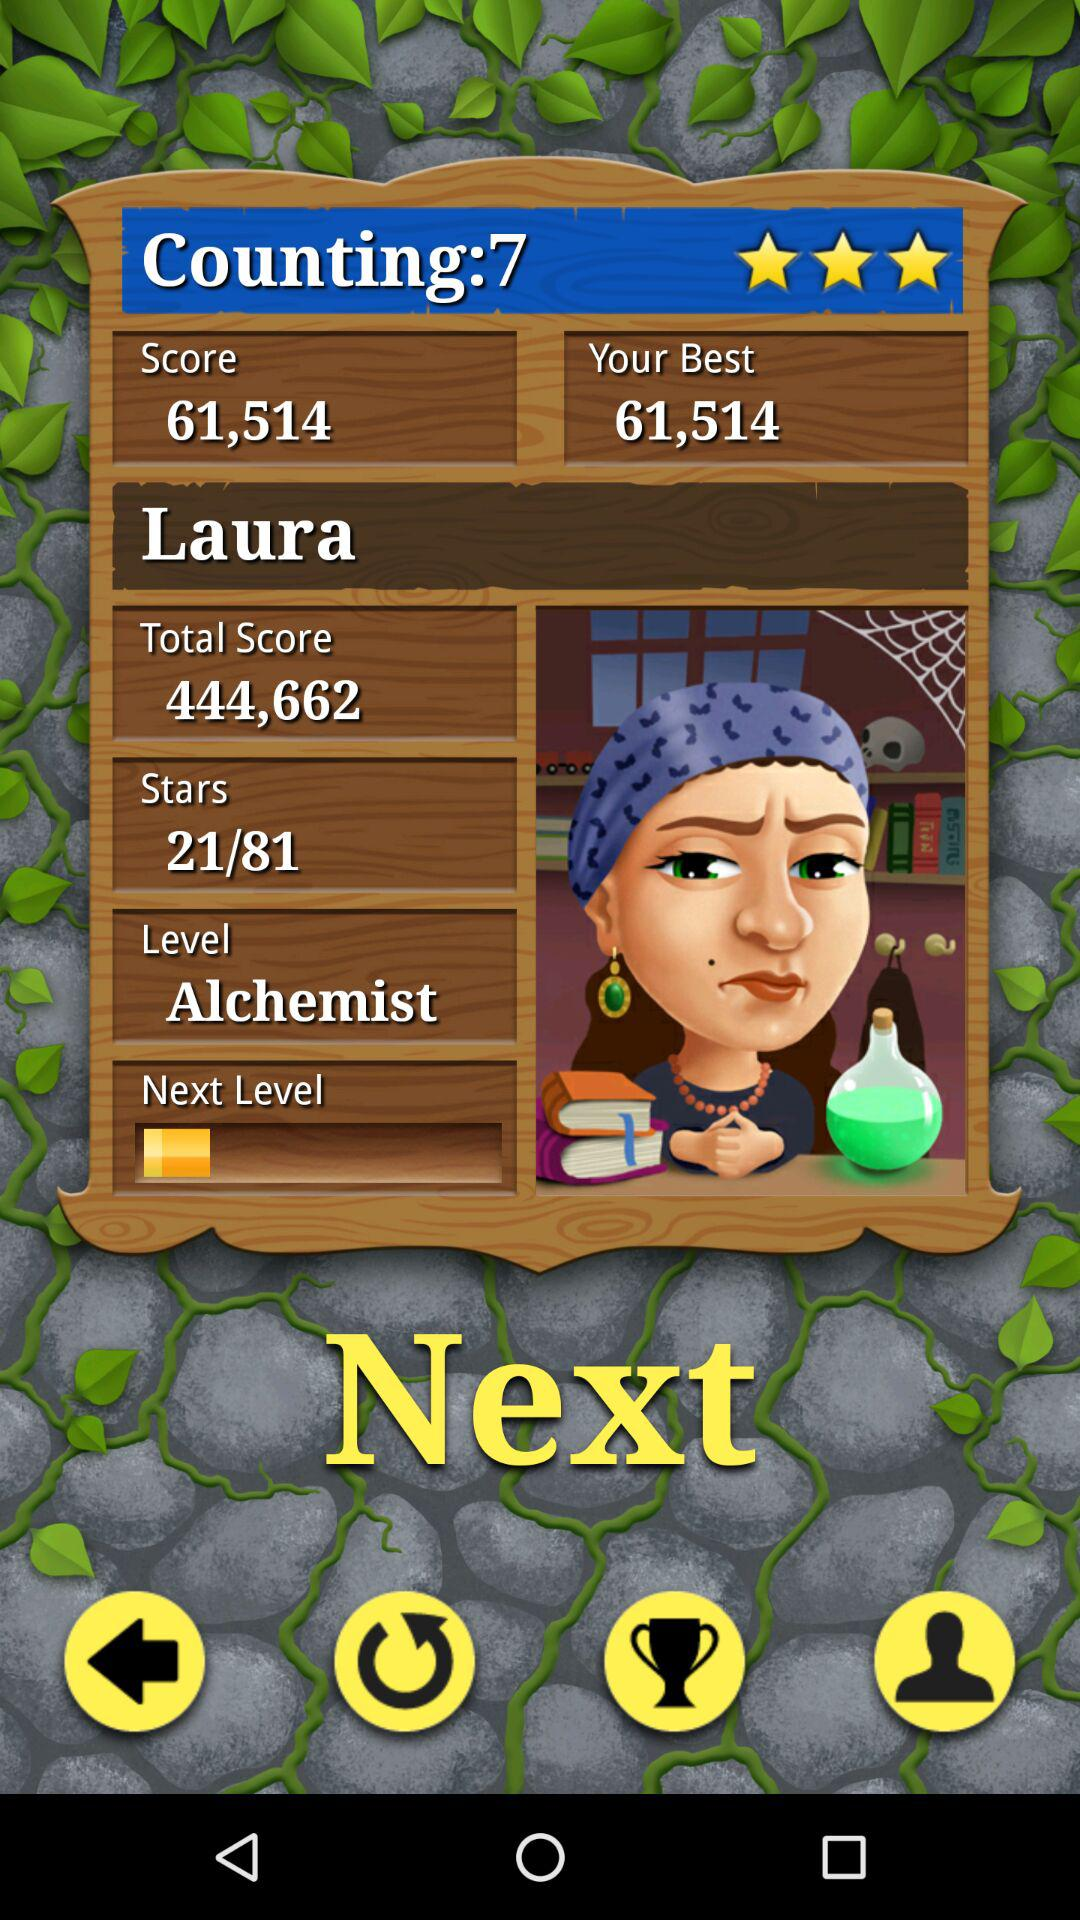What is the score? The score is 61,514. 